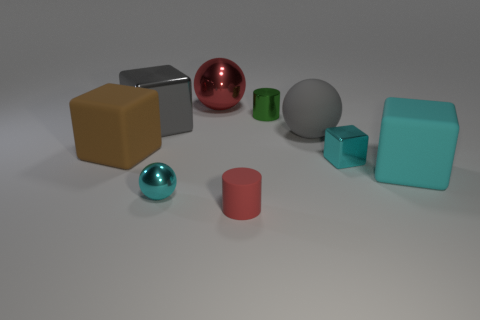How many other objects are the same material as the red cylinder?
Your response must be concise. 3. Do the big red ball and the tiny thing that is behind the large brown rubber block have the same material?
Provide a short and direct response. Yes. Is the number of cyan things right of the gray matte ball less than the number of gray spheres to the left of the large cyan thing?
Your response must be concise. No. There is a cylinder behind the large gray rubber sphere; what color is it?
Offer a terse response. Green. What number of other objects are there of the same color as the large matte ball?
Offer a very short reply. 1. Do the metallic sphere behind the gray matte sphere and the tiny matte thing have the same size?
Ensure brevity in your answer.  No. How many small green metal objects are left of the small shiny block?
Give a very brief answer. 1. Is there a brown rubber cube that has the same size as the red cylinder?
Make the answer very short. No. Does the big shiny block have the same color as the shiny cylinder?
Offer a very short reply. No. What is the color of the metallic ball behind the metallic thing that is in front of the small metallic block?
Offer a very short reply. Red. 